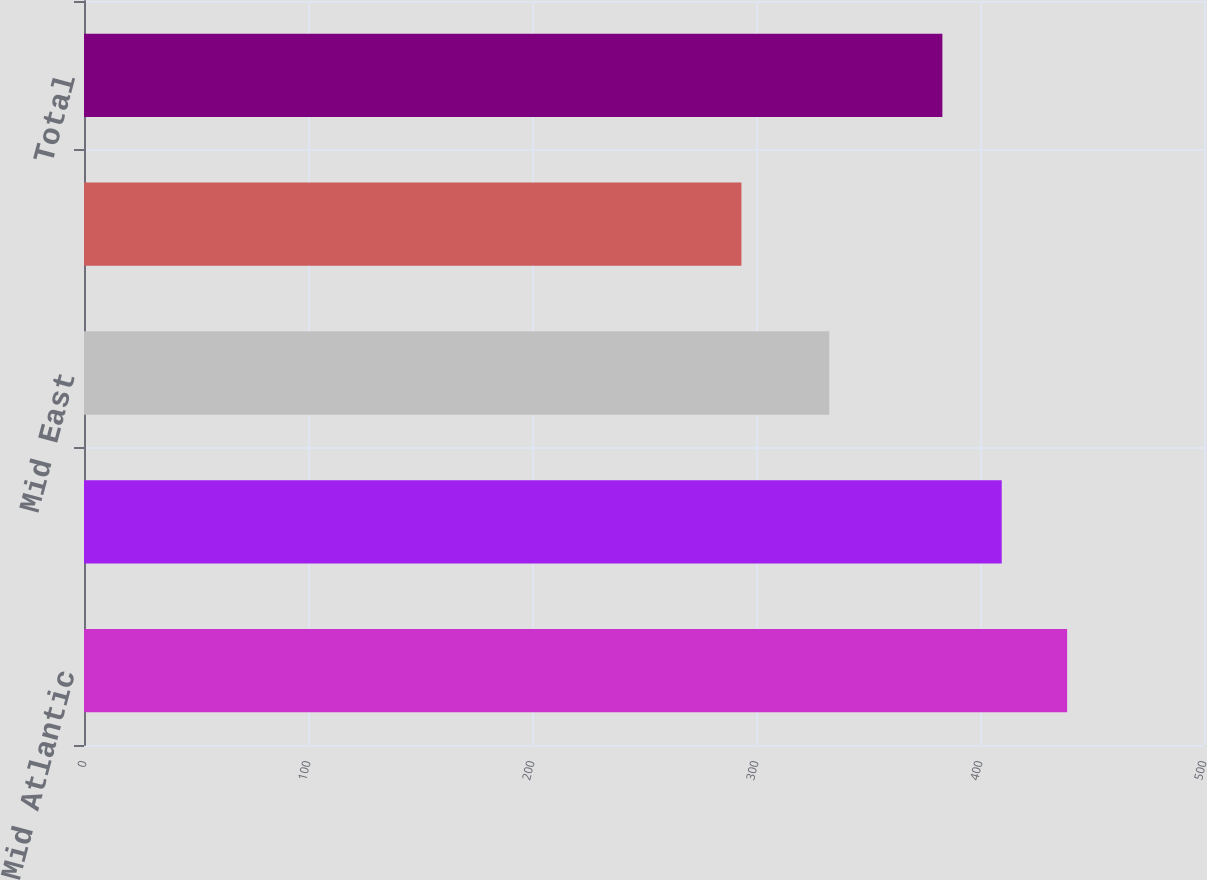Convert chart to OTSL. <chart><loc_0><loc_0><loc_500><loc_500><bar_chart><fcel>Mid Atlantic<fcel>North East<fcel>Mid East<fcel>South East<fcel>Total<nl><fcel>438.9<fcel>409.7<fcel>332.7<fcel>293.5<fcel>383.2<nl></chart> 